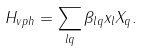<formula> <loc_0><loc_0><loc_500><loc_500>H _ { v p h } = \sum _ { l q } \beta _ { l q } x _ { l } X _ { q } .</formula> 